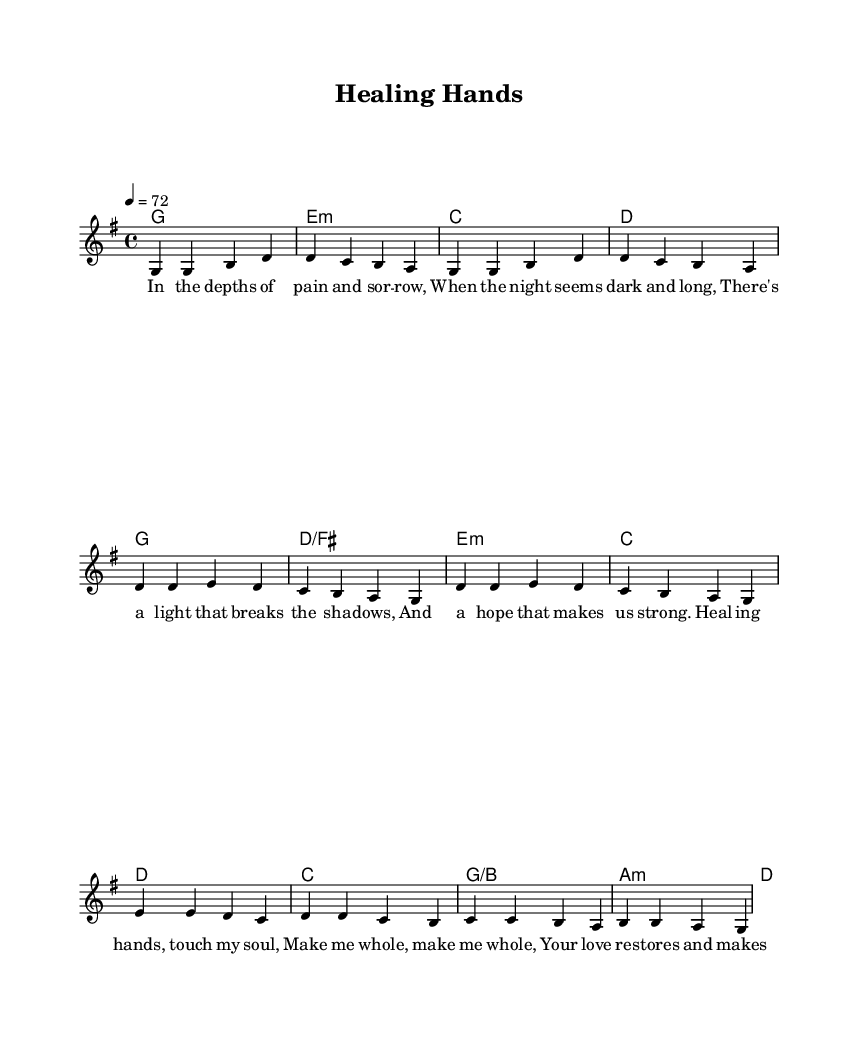What is the key signature of this music? The key signature shown in the music is G major, which has one sharp (F#).
Answer: G major What is the time signature of this music? The time signature indicated in the music is 4/4, shown at the beginning of the score.
Answer: 4/4 What is the tempo marking for this music? The tempo marking is set at 72 beats per minute, noted in quarter note equals 72.
Answer: 72 How many verses are included in the lyrics? The lyrics provided in the music contain one verse section before the chorus.
Answer: One What is the mood or theme of the song? The song focuses on themes of healing and restoration, evident from the lyrics describing hope and renewal.
Answer: Healing and restoration What chord is used in the bridge? The bridge section has an A minor chord, which is indicated in the harmony part.
Answer: A minor How many lines are in the chorus lyrics? The chorus lyrics consist of four lines, as shown in the lyric section below the melody.
Answer: Four lines 